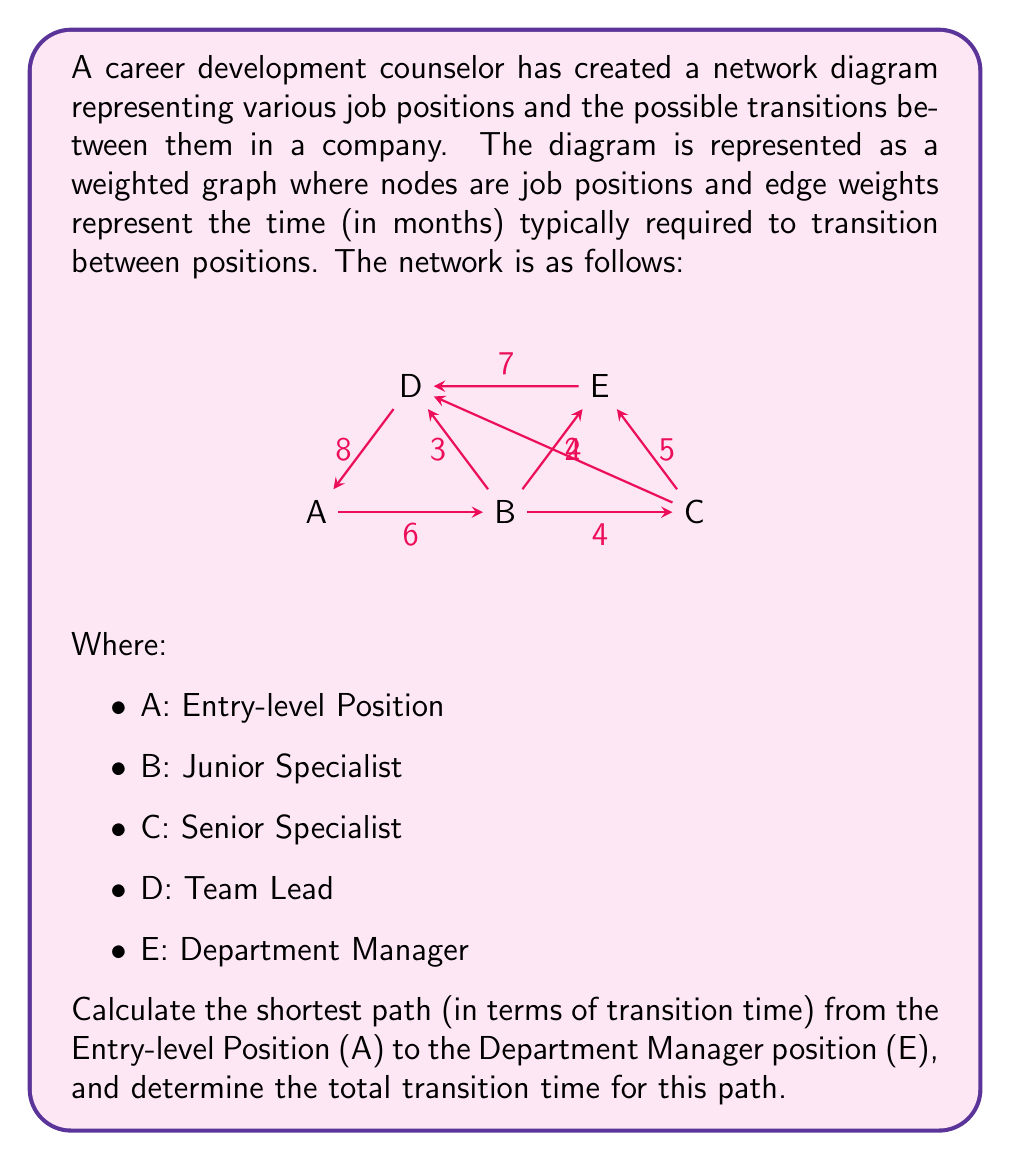Provide a solution to this math problem. To solve this problem, we can use Dijkstra's algorithm to find the shortest path from node A to node E in the weighted graph.

Step 1: Initialize distances
Set the distance to A as 0 and all other nodes as infinity.
$d(A) = 0$, $d(B) = d(C) = d(D) = d(E) = \infty$

Step 2: Visit node A
Update distances to neighboring nodes:
$d(B) = 6$, $d(D) = 8$

Step 3: Visit node B (shortest distance from unvisited nodes)
Update distances:
$d(D) = \min(d(D), d(B) + 3) = \min(8, 9) = 8$
$d(E) = d(B) + 2 = 8$

Step 4: Visit node E (shortest distance from unvisited nodes)
No updates needed as E is our target node.

The shortest path is A → B → E with a total distance of 8 months.

To verify:
A → B: 6 months
B → E: 2 months
Total: 6 + 2 = 8 months

This path represents the quickest career progression from Entry-level Position to Department Manager.
Answer: The shortest path from Entry-level Position (A) to Department Manager (E) is A → B → E, with a total transition time of 8 months. 